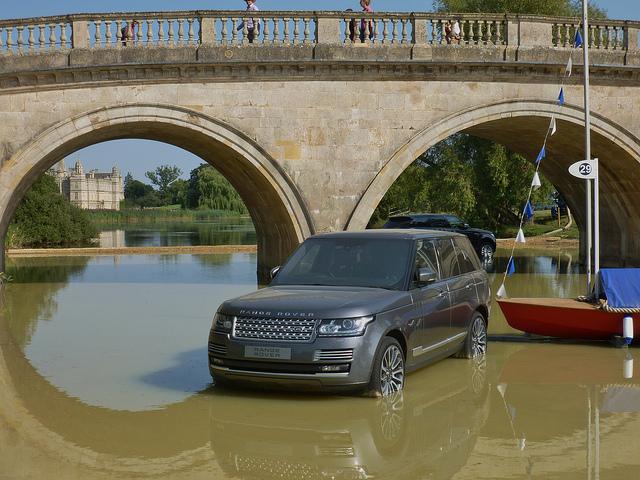What color is the water?
Give a very brief answer. Brown. Should the car be parked here?
Answer briefly. No. Why is he in the water?
Write a very short answer. Flood. Which transportation should be in the water?
Short answer required. Boat. 